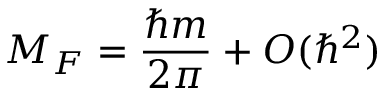<formula> <loc_0><loc_0><loc_500><loc_500>M _ { F } = \frac { \hbar { m } } { 2 \pi } + O ( \hbar { ^ } { 2 } )</formula> 